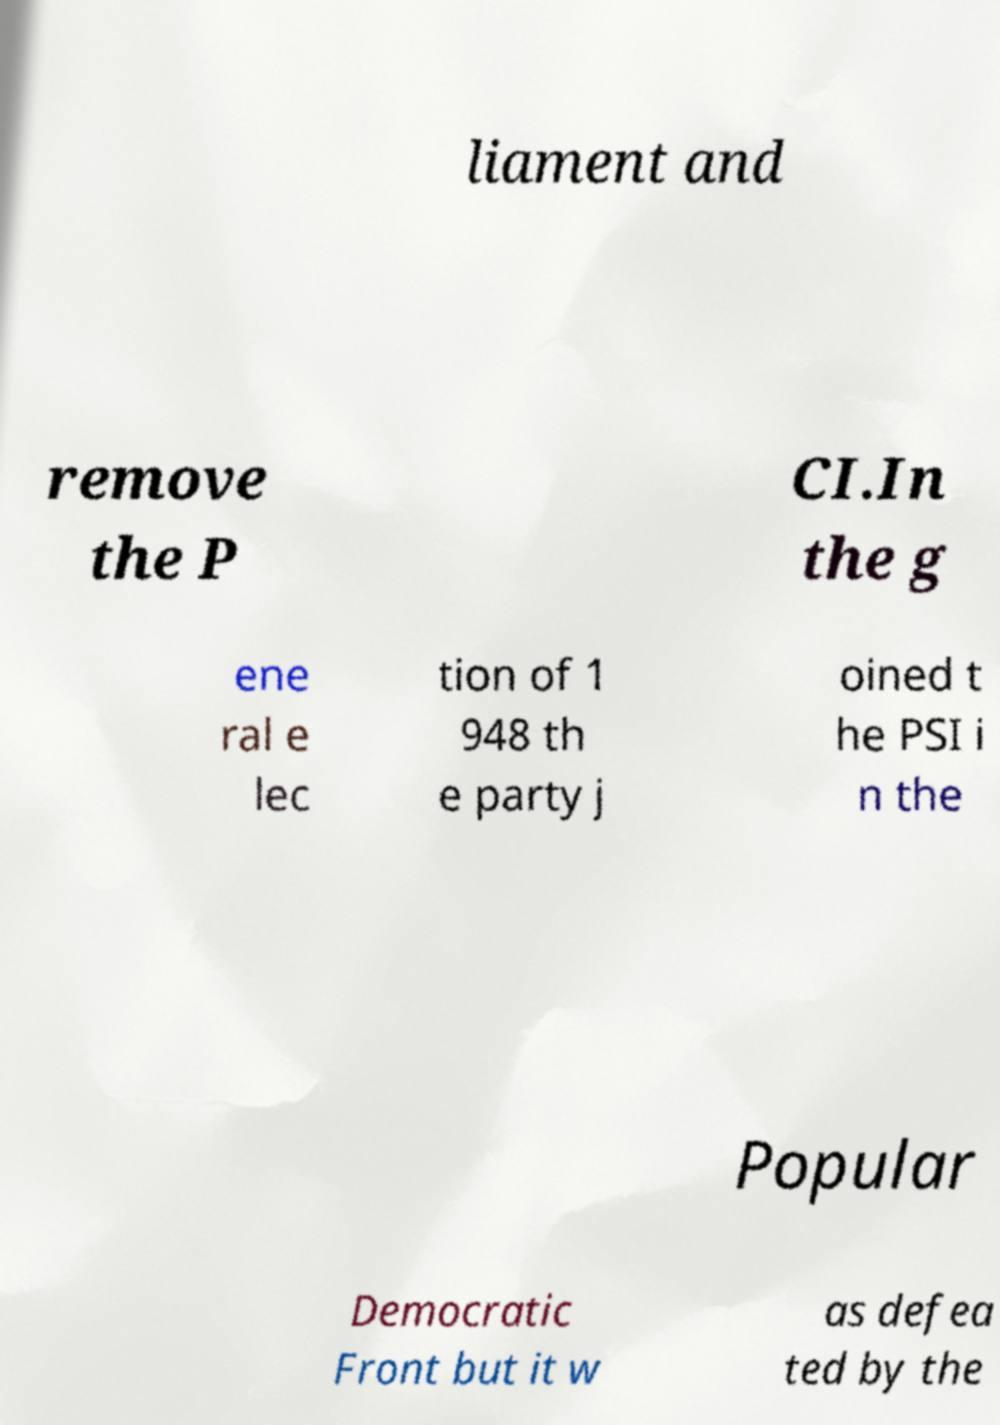I need the written content from this picture converted into text. Can you do that? liament and remove the P CI.In the g ene ral e lec tion of 1 948 th e party j oined t he PSI i n the Popular Democratic Front but it w as defea ted by the 